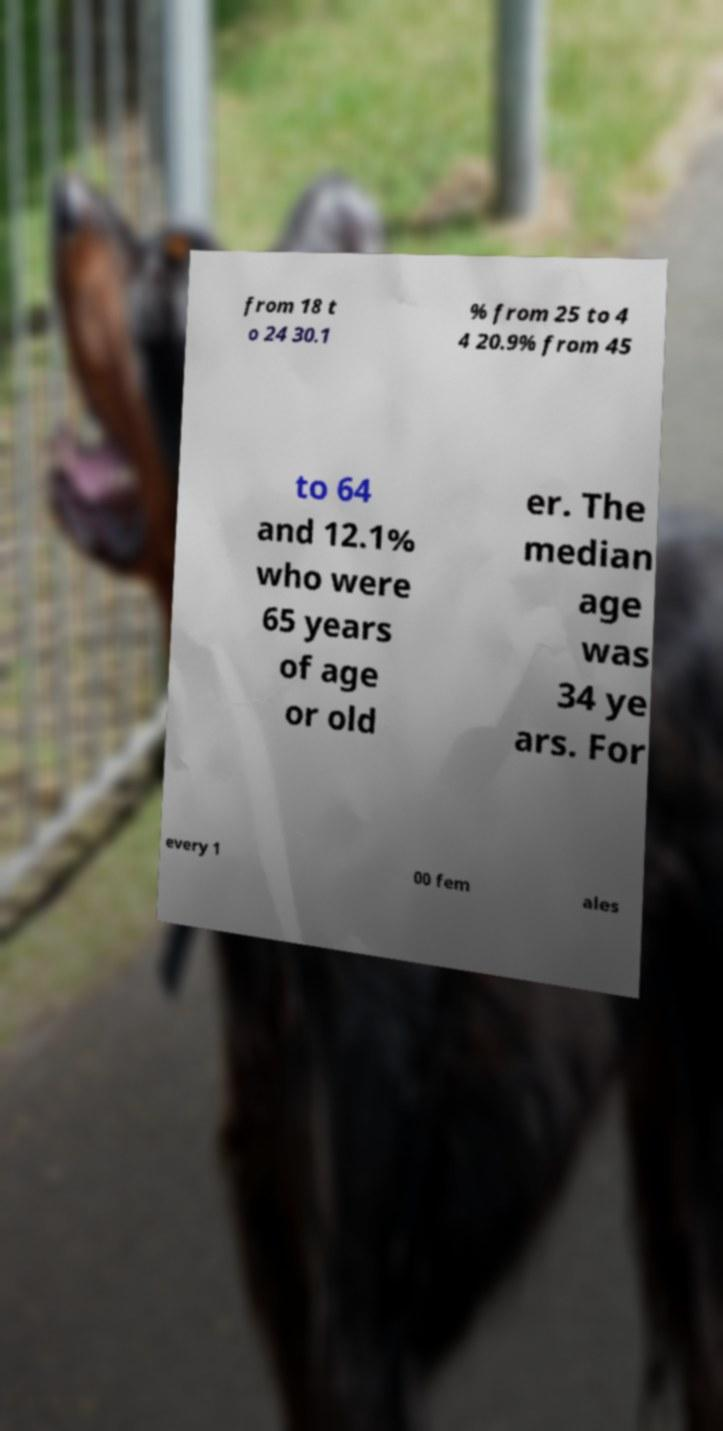Could you extract and type out the text from this image? from 18 t o 24 30.1 % from 25 to 4 4 20.9% from 45 to 64 and 12.1% who were 65 years of age or old er. The median age was 34 ye ars. For every 1 00 fem ales 